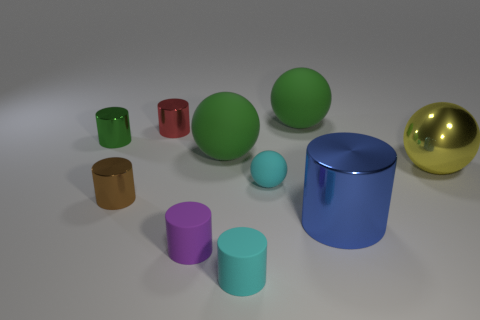Subtract 3 cylinders. How many cylinders are left? 3 Subtract all green cylinders. How many cylinders are left? 5 Subtract all brown metal cylinders. How many cylinders are left? 5 Subtract all cyan balls. Subtract all red cubes. How many balls are left? 3 Subtract all balls. How many objects are left? 6 Add 9 large blue objects. How many large blue objects exist? 10 Subtract 1 yellow balls. How many objects are left? 9 Subtract all small green cylinders. Subtract all green spheres. How many objects are left? 7 Add 9 red things. How many red things are left? 10 